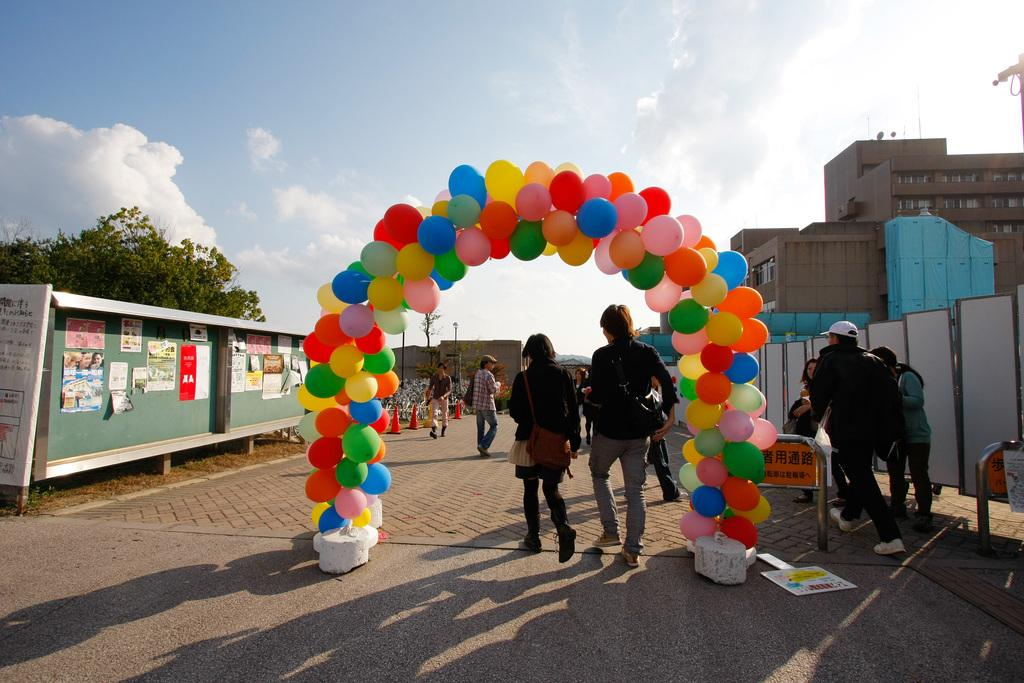How many people can be seen in the image? There are people in the image, but the exact number is not specified. What type of infrastructure is present in the image? There is a road, poles, a shed, and buildings visible in the image. What objects are used to direct traffic in the image? Traffic cones are present in the image. What type of vegetation is visible in the image? Trees are present in the image. What items are used for display or communication in the image? Boards, a banner, and posters are in the image. What is visible in the background of the image? The sky is visible in the background of the image, with clouds present. Can you see a carriage being pulled by horses in the image? No, there is no carriage or horses present in the image. Is there a sock hanging from one of the trees in the image? No, there is no sock visible in the image. 